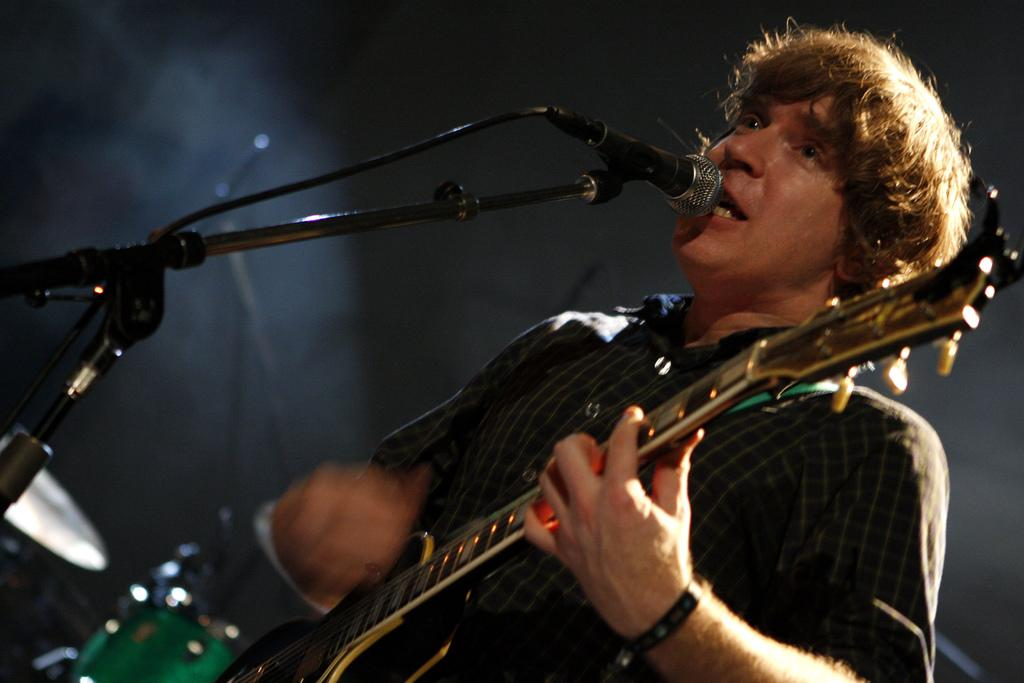What is the man in the image doing? The man is singing and playing the guitar. What is the man holding in the image? The man is holding a microphone. What can be seen in the background of the image? There are drums in the background of the image. What is happening to the man from the top? There is a light flashing on the man from the top. What type of unit can be seen on the man's ear in the image? There is no unit visible on the man's ear in the image. What does the taste of the guitar sound like in the image? The taste of the guitar sound cannot be determined from the image, as taste is a sense related to food and not music. 